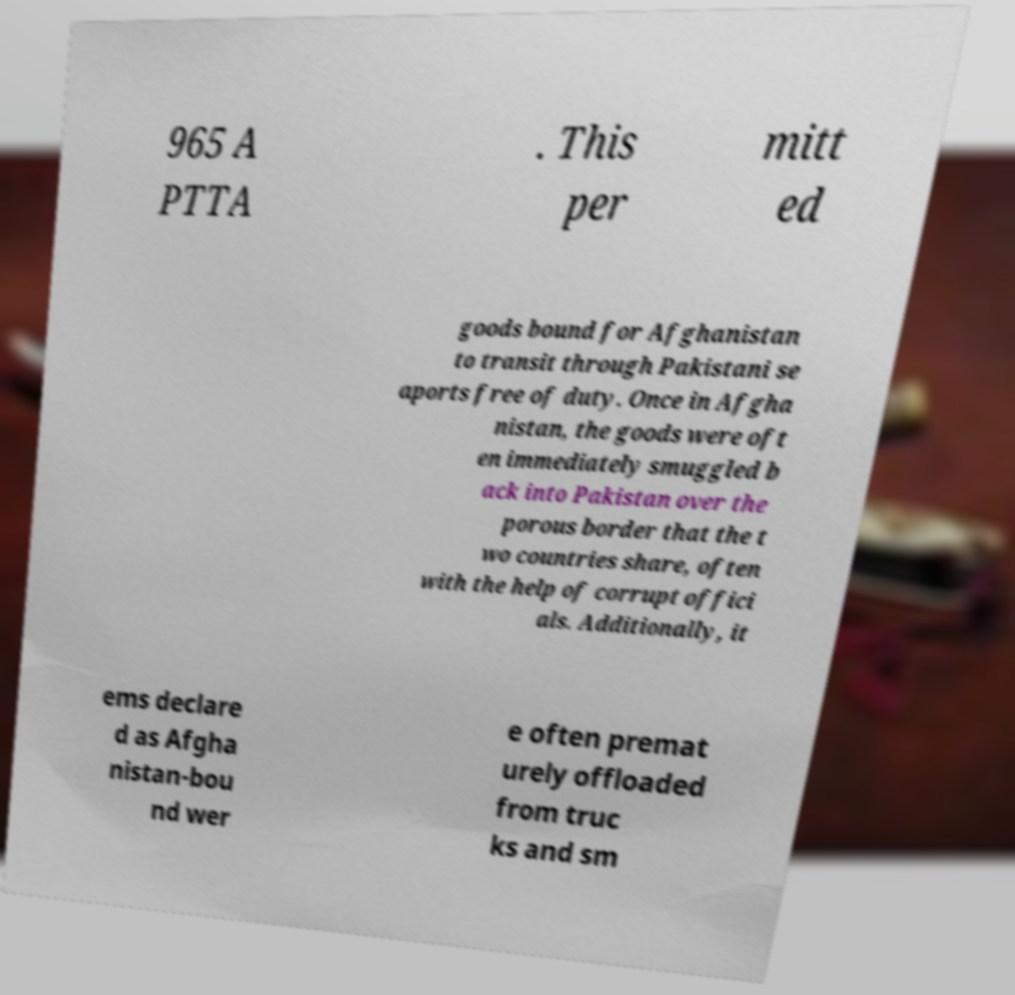Please read and relay the text visible in this image. What does it say? 965 A PTTA . This per mitt ed goods bound for Afghanistan to transit through Pakistani se aports free of duty. Once in Afgha nistan, the goods were oft en immediately smuggled b ack into Pakistan over the porous border that the t wo countries share, often with the help of corrupt offici als. Additionally, it ems declare d as Afgha nistan-bou nd wer e often premat urely offloaded from truc ks and sm 